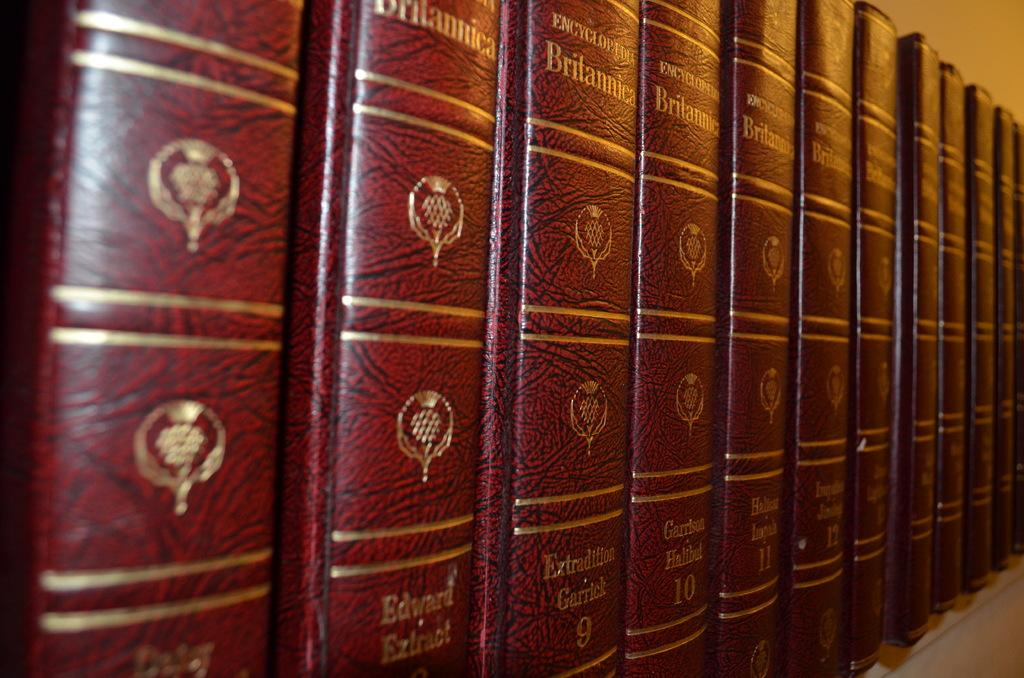<image>
Render a clear and concise summary of the photo. A set of red bound encyclopedia Britannicas lined up in a row. 